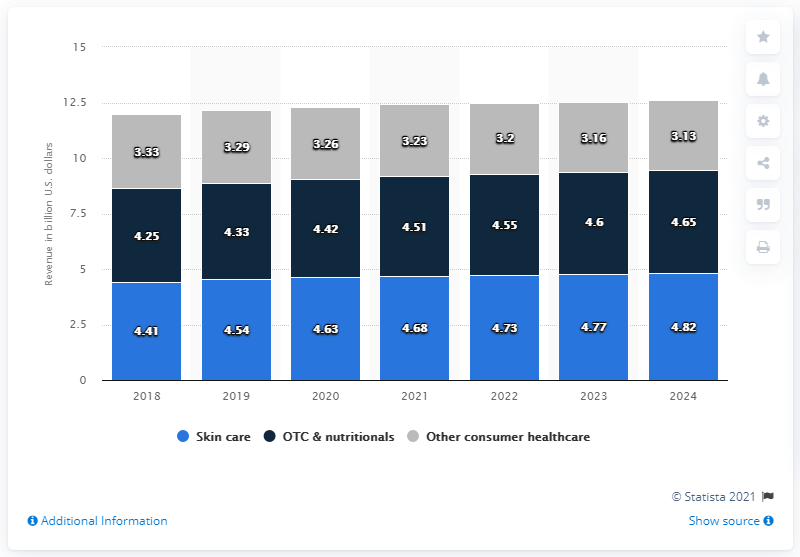Indicate a few pertinent items in this graphic. In 2018, the estimated value of the consumer healthcare segment of Johnson & Johnson was approximately 3.33 dollars. 